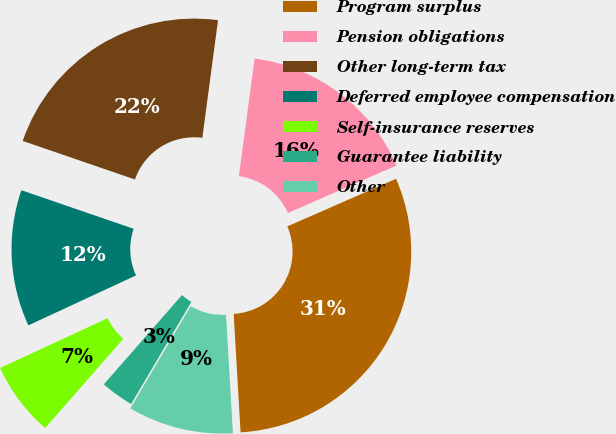<chart> <loc_0><loc_0><loc_500><loc_500><pie_chart><fcel>Program surplus<fcel>Pension obligations<fcel>Other long-term tax<fcel>Deferred employee compensation<fcel>Self-insurance reserves<fcel>Guarantee liability<fcel>Other<nl><fcel>30.64%<fcel>16.32%<fcel>21.84%<fcel>12.18%<fcel>6.64%<fcel>2.96%<fcel>9.41%<nl></chart> 